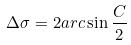<formula> <loc_0><loc_0><loc_500><loc_500>\Delta \sigma = 2 a r c \sin \frac { C } { 2 }</formula> 